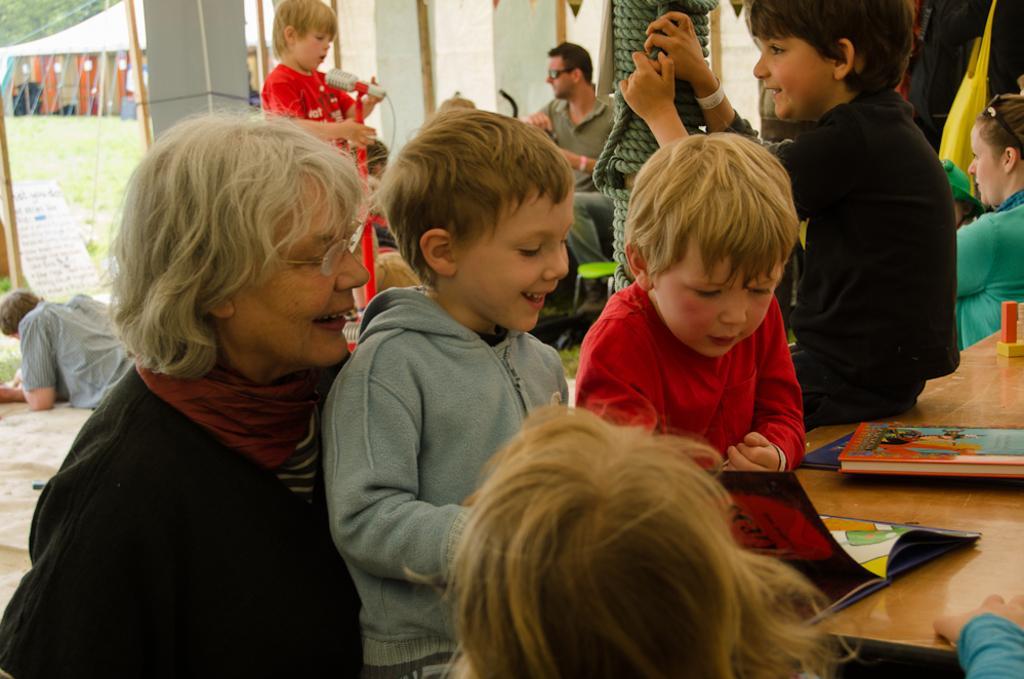How would you summarize this image in a sentence or two? In this image I can see people and children. In the background I can see a microphone and other objects. On the right side I can see a table. On the table I can see books and other objects. 